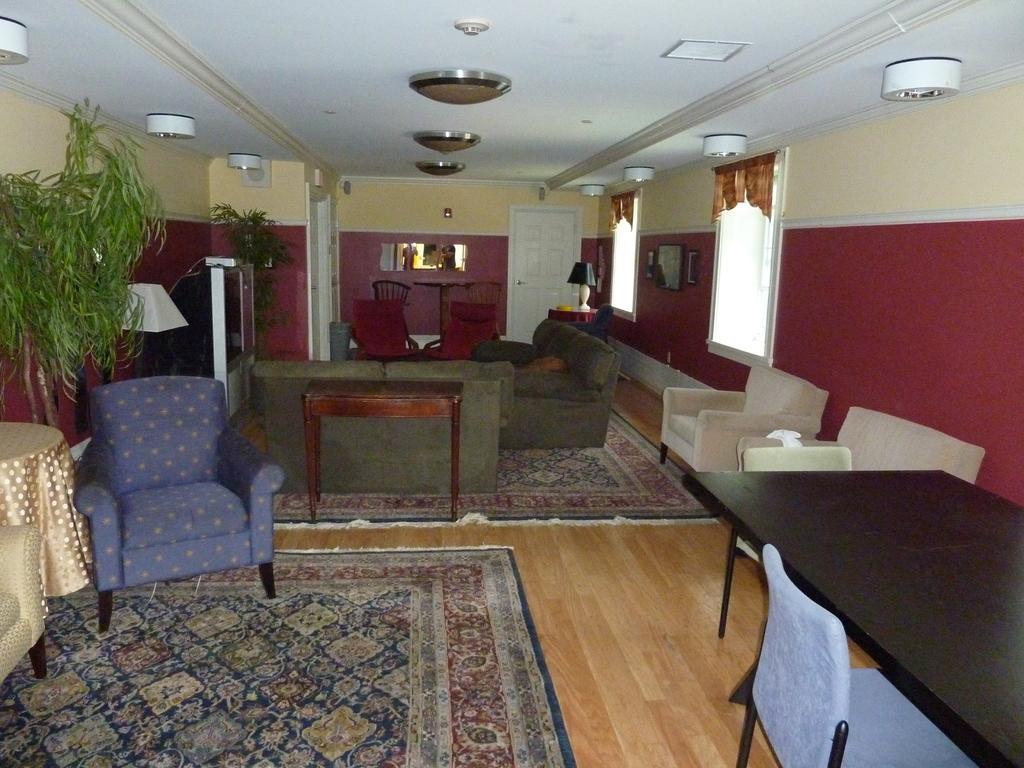Could you give a brief overview of what you see in this image? In this image I see a room, in which there is a sofa set and 2 tables, windows and doors and the plants. 